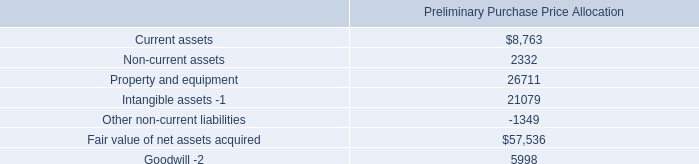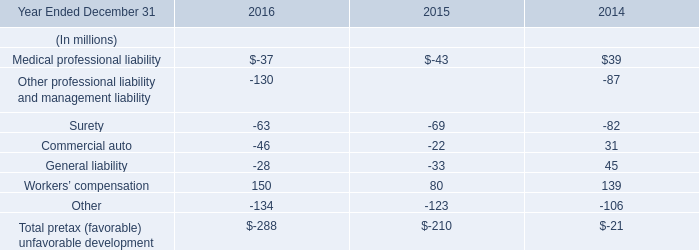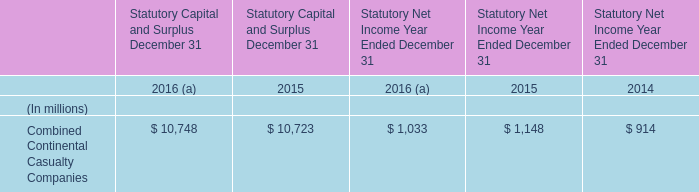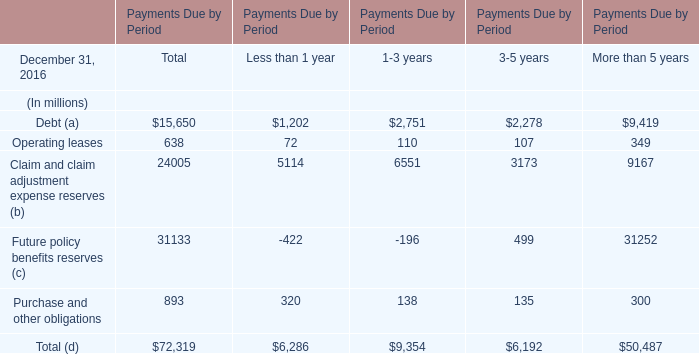What is the 50% of the value of the Claim and claim adjustment expense reserves for 1-3 years? (in million) 
Computations: (0.5 * 6551)
Answer: 3275.5. 